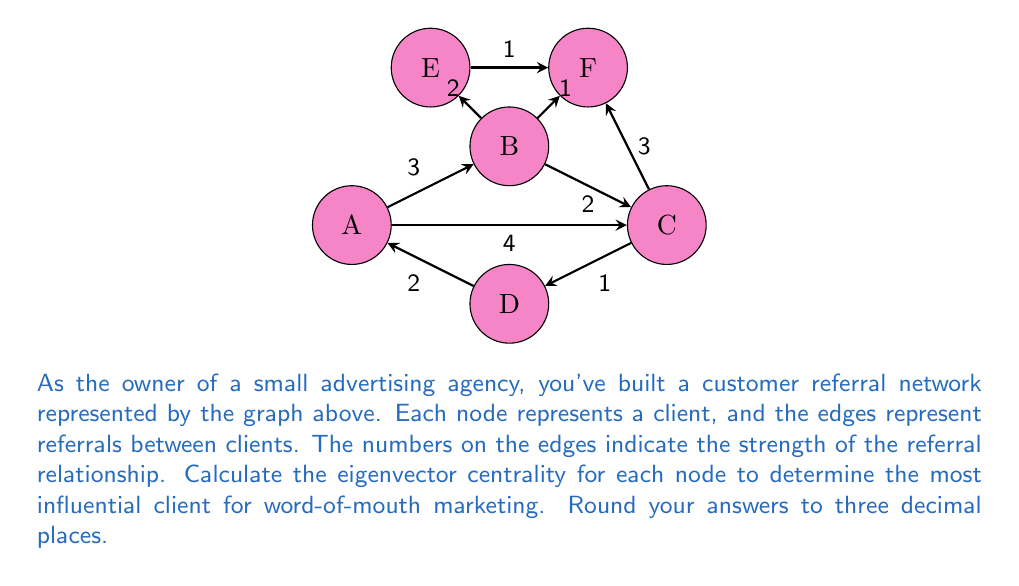Can you answer this question? To solve this problem, we'll follow these steps:

1) First, we need to create the adjacency matrix A for the graph. The adjacency matrix will be:

$$
A = \begin{bmatrix}
0 & 3 & 4 & 2 & 0 & 0 \\
3 & 0 & 2 & 0 & 2 & 1 \\
4 & 2 & 0 & 1 & 0 & 3 \\
2 & 0 & 1 & 0 & 0 & 0 \\
0 & 2 & 0 & 0 & 0 & 1 \\
0 & 1 & 3 & 0 & 1 & 0
\end{bmatrix}
$$

2) The eigenvector centrality is given by the equation:

$$ Ax = \lambda x $$

Where $\lambda$ is the largest eigenvalue and $x$ is the corresponding eigenvector.

3) We can use power iteration to find the eigenvector:
   - Start with an initial guess $x_0 = [1, 1, 1, 1, 1, 1]^T$
   - Repeatedly multiply by A and normalize:
     $x_{k+1} = \frac{Ax_k}{\|Ax_k\|}$

4) After several iterations, we get the eigenvector:

$$ x \approx [0.4405, 0.4714, 0.5768, 0.1850, 0.1850, 0.3936]^T $$

5) Normalizing this vector so that the largest value is 1:

$$ x_{normalized} \approx [0.764, 0.817, 1.000, 0.321, 0.321, 0.682]^T $$

6) These values represent the relative importance of each node (A, B, C, D, E, F) in the network.
Answer: C (1.000), B (0.817), A (0.764), F (0.682), D (0.321), E (0.321) 